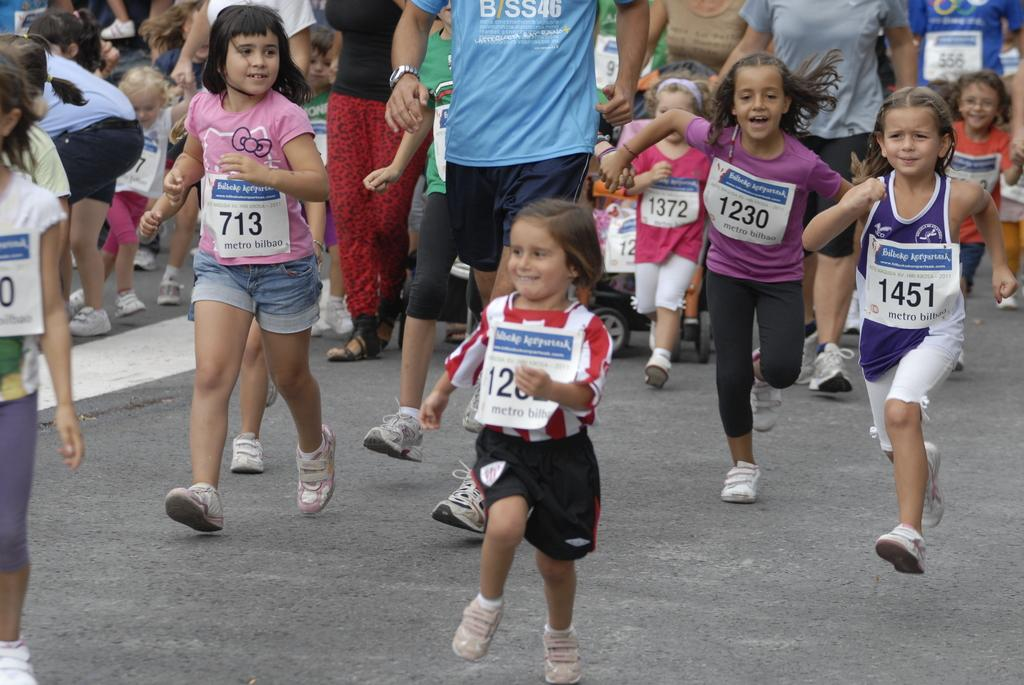<image>
Render a clear and concise summary of the photo. The girls in the picture are racing for metro milbao. 